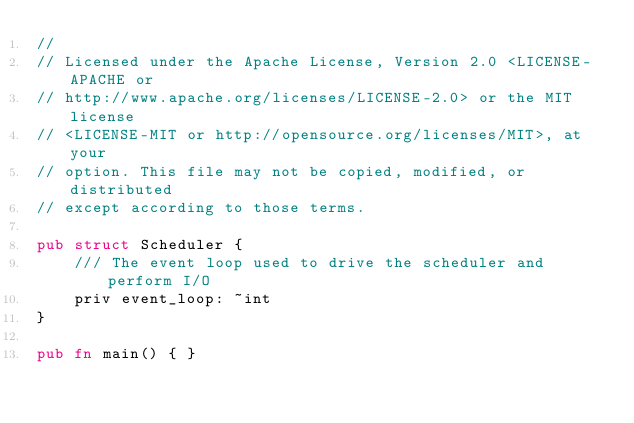Convert code to text. <code><loc_0><loc_0><loc_500><loc_500><_Rust_>//
// Licensed under the Apache License, Version 2.0 <LICENSE-APACHE or
// http://www.apache.org/licenses/LICENSE-2.0> or the MIT license
// <LICENSE-MIT or http://opensource.org/licenses/MIT>, at your
// option. This file may not be copied, modified, or distributed
// except according to those terms.

pub struct Scheduler {
    /// The event loop used to drive the scheduler and perform I/O
    priv event_loop: ~int
}

pub fn main() { }
</code> 